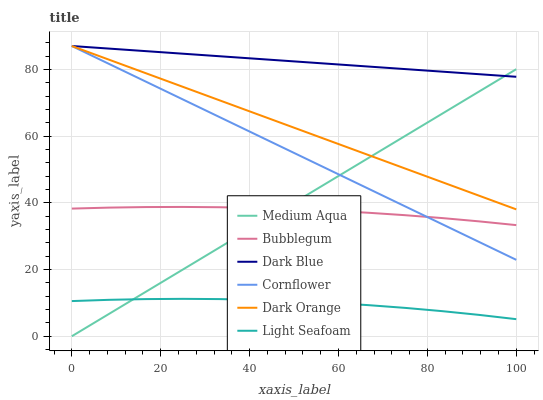Does Light Seafoam have the minimum area under the curve?
Answer yes or no. Yes. Does Dark Blue have the maximum area under the curve?
Answer yes or no. Yes. Does Cornflower have the minimum area under the curve?
Answer yes or no. No. Does Cornflower have the maximum area under the curve?
Answer yes or no. No. Is Medium Aqua the smoothest?
Answer yes or no. Yes. Is Light Seafoam the roughest?
Answer yes or no. Yes. Is Cornflower the smoothest?
Answer yes or no. No. Is Cornflower the roughest?
Answer yes or no. No. Does Cornflower have the lowest value?
Answer yes or no. No. Does Bubblegum have the highest value?
Answer yes or no. No. Is Light Seafoam less than Cornflower?
Answer yes or no. Yes. Is Bubblegum greater than Light Seafoam?
Answer yes or no. Yes. Does Light Seafoam intersect Cornflower?
Answer yes or no. No. 